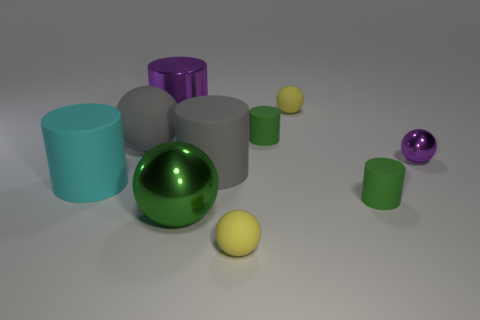Subtract all gray rubber cylinders. How many cylinders are left? 4 Subtract all cyan cylinders. How many cylinders are left? 4 Subtract all cyan spheres. How many green cylinders are left? 2 Subtract 0 blue cylinders. How many objects are left? 10 Subtract 3 cylinders. How many cylinders are left? 2 Subtract all red balls. Subtract all green blocks. How many balls are left? 5 Subtract all green balls. Subtract all big rubber spheres. How many objects are left? 8 Add 7 green metal balls. How many green metal balls are left? 8 Add 4 tiny purple matte cylinders. How many tiny purple matte cylinders exist? 4 